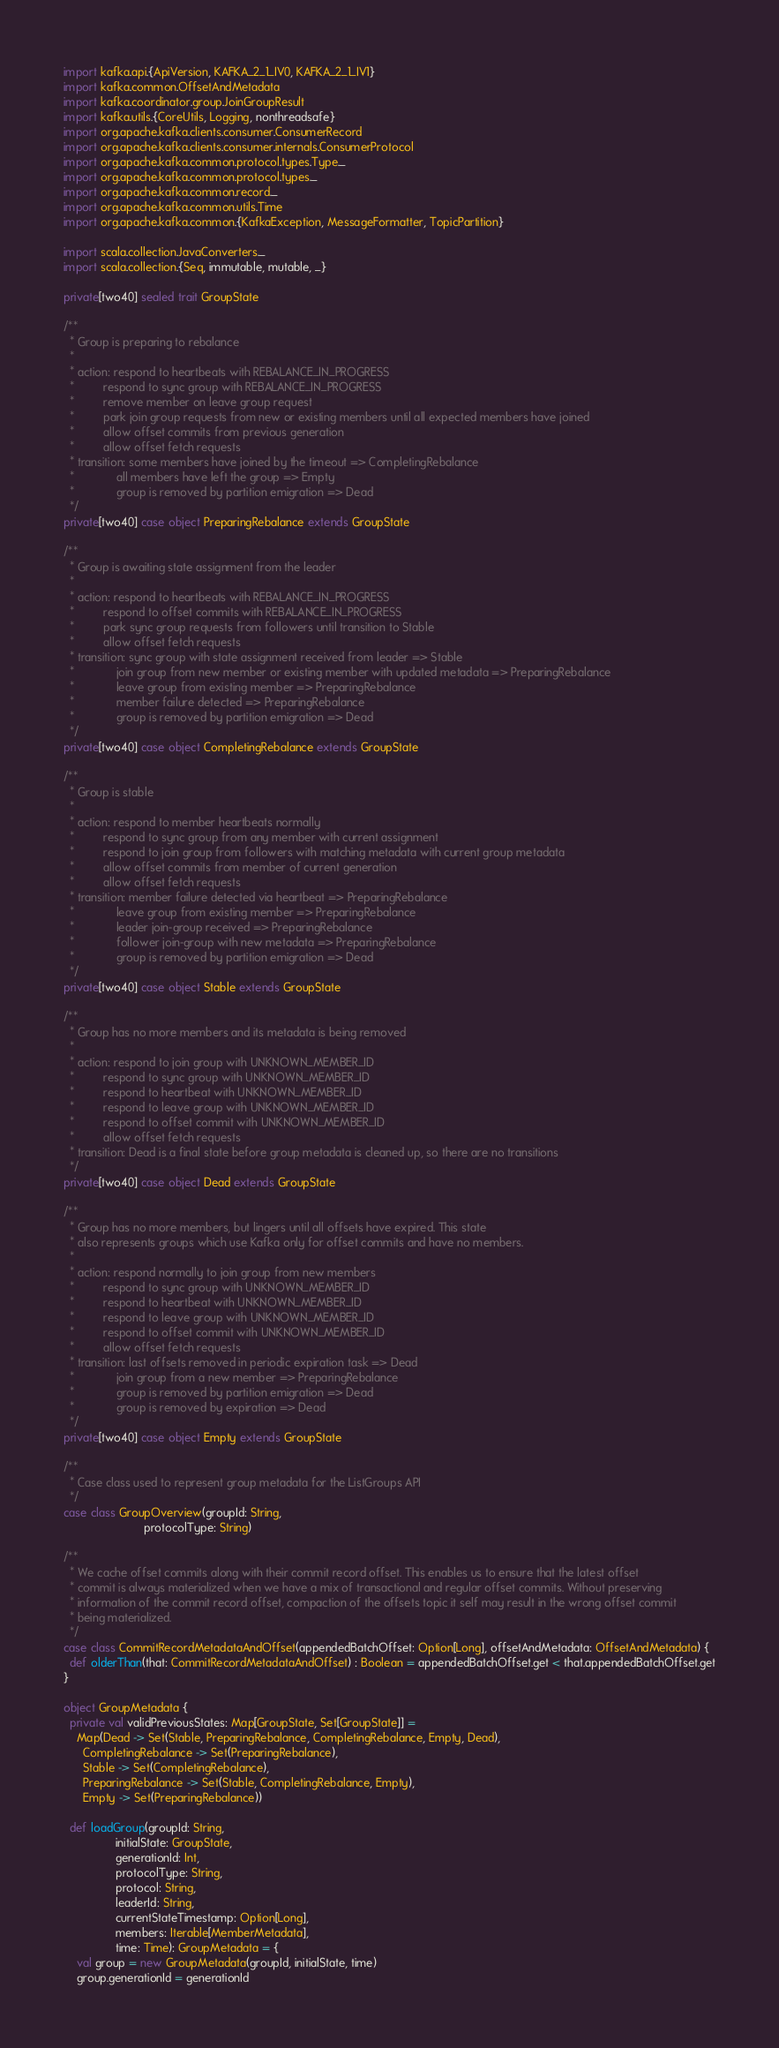<code> <loc_0><loc_0><loc_500><loc_500><_Scala_>import kafka.api.{ApiVersion, KAFKA_2_1_IV0, KAFKA_2_1_IV1}
import kafka.common.OffsetAndMetadata
import kafka.coordinator.group.JoinGroupResult
import kafka.utils.{CoreUtils, Logging, nonthreadsafe}
import org.apache.kafka.clients.consumer.ConsumerRecord
import org.apache.kafka.clients.consumer.internals.ConsumerProtocol
import org.apache.kafka.common.protocol.types.Type._
import org.apache.kafka.common.protocol.types._
import org.apache.kafka.common.record._
import org.apache.kafka.common.utils.Time
import org.apache.kafka.common.{KafkaException, MessageFormatter, TopicPartition}

import scala.collection.JavaConverters._
import scala.collection.{Seq, immutable, mutable, _}

private[two40] sealed trait GroupState

/**
  * Group is preparing to rebalance
  *
  * action: respond to heartbeats with REBALANCE_IN_PROGRESS
  *         respond to sync group with REBALANCE_IN_PROGRESS
  *         remove member on leave group request
  *         park join group requests from new or existing members until all expected members have joined
  *         allow offset commits from previous generation
  *         allow offset fetch requests
  * transition: some members have joined by the timeout => CompletingRebalance
  *             all members have left the group => Empty
  *             group is removed by partition emigration => Dead
  */
private[two40] case object PreparingRebalance extends GroupState

/**
  * Group is awaiting state assignment from the leader
  *
  * action: respond to heartbeats with REBALANCE_IN_PROGRESS
  *         respond to offset commits with REBALANCE_IN_PROGRESS
  *         park sync group requests from followers until transition to Stable
  *         allow offset fetch requests
  * transition: sync group with state assignment received from leader => Stable
  *             join group from new member or existing member with updated metadata => PreparingRebalance
  *             leave group from existing member => PreparingRebalance
  *             member failure detected => PreparingRebalance
  *             group is removed by partition emigration => Dead
  */
private[two40] case object CompletingRebalance extends GroupState

/**
  * Group is stable
  *
  * action: respond to member heartbeats normally
  *         respond to sync group from any member with current assignment
  *         respond to join group from followers with matching metadata with current group metadata
  *         allow offset commits from member of current generation
  *         allow offset fetch requests
  * transition: member failure detected via heartbeat => PreparingRebalance
  *             leave group from existing member => PreparingRebalance
  *             leader join-group received => PreparingRebalance
  *             follower join-group with new metadata => PreparingRebalance
  *             group is removed by partition emigration => Dead
  */
private[two40] case object Stable extends GroupState

/**
  * Group has no more members and its metadata is being removed
  *
  * action: respond to join group with UNKNOWN_MEMBER_ID
  *         respond to sync group with UNKNOWN_MEMBER_ID
  *         respond to heartbeat with UNKNOWN_MEMBER_ID
  *         respond to leave group with UNKNOWN_MEMBER_ID
  *         respond to offset commit with UNKNOWN_MEMBER_ID
  *         allow offset fetch requests
  * transition: Dead is a final state before group metadata is cleaned up, so there are no transitions
  */
private[two40] case object Dead extends GroupState

/**
  * Group has no more members, but lingers until all offsets have expired. This state
  * also represents groups which use Kafka only for offset commits and have no members.
  *
  * action: respond normally to join group from new members
  *         respond to sync group with UNKNOWN_MEMBER_ID
  *         respond to heartbeat with UNKNOWN_MEMBER_ID
  *         respond to leave group with UNKNOWN_MEMBER_ID
  *         respond to offset commit with UNKNOWN_MEMBER_ID
  *         allow offset fetch requests
  * transition: last offsets removed in periodic expiration task => Dead
  *             join group from a new member => PreparingRebalance
  *             group is removed by partition emigration => Dead
  *             group is removed by expiration => Dead
  */
private[two40] case object Empty extends GroupState

/**
  * Case class used to represent group metadata for the ListGroups API
  */
case class GroupOverview(groupId: String,
                         protocolType: String)

/**
  * We cache offset commits along with their commit record offset. This enables us to ensure that the latest offset
  * commit is always materialized when we have a mix of transactional and regular offset commits. Without preserving
  * information of the commit record offset, compaction of the offsets topic it self may result in the wrong offset commit
  * being materialized.
  */
case class CommitRecordMetadataAndOffset(appendedBatchOffset: Option[Long], offsetAndMetadata: OffsetAndMetadata) {
  def olderThan(that: CommitRecordMetadataAndOffset) : Boolean = appendedBatchOffset.get < that.appendedBatchOffset.get
}

object GroupMetadata {
  private val validPreviousStates: Map[GroupState, Set[GroupState]] =
    Map(Dead -> Set(Stable, PreparingRebalance, CompletingRebalance, Empty, Dead),
      CompletingRebalance -> Set(PreparingRebalance),
      Stable -> Set(CompletingRebalance),
      PreparingRebalance -> Set(Stable, CompletingRebalance, Empty),
      Empty -> Set(PreparingRebalance))

  def loadGroup(groupId: String,
                initialState: GroupState,
                generationId: Int,
                protocolType: String,
                protocol: String,
                leaderId: String,
                currentStateTimestamp: Option[Long],
                members: Iterable[MemberMetadata],
                time: Time): GroupMetadata = {
    val group = new GroupMetadata(groupId, initialState, time)
    group.generationId = generationId</code> 